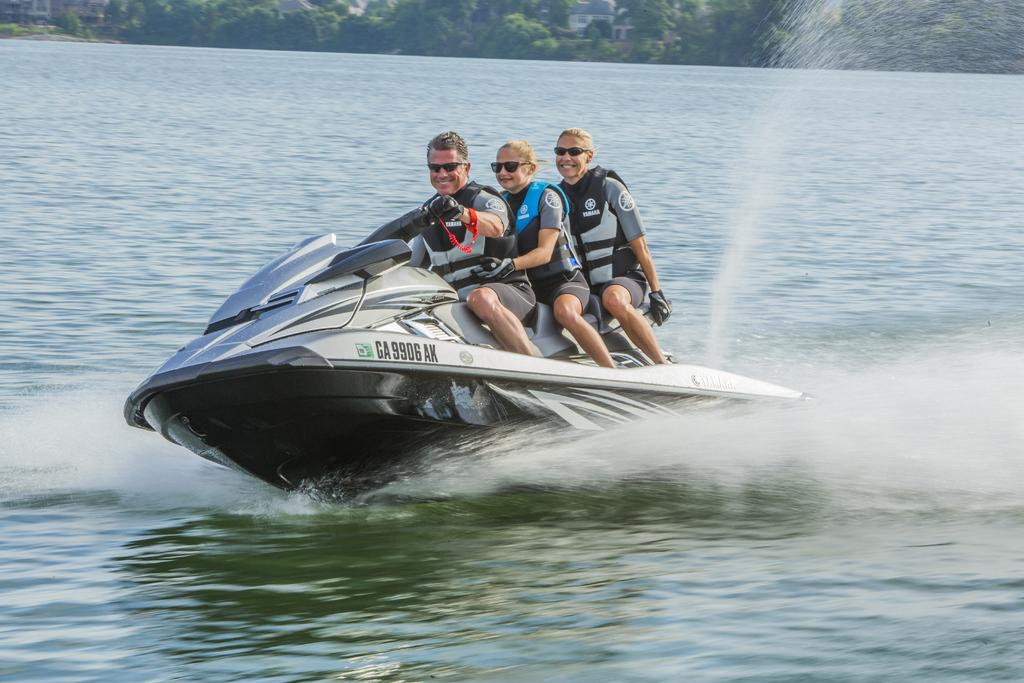How many people are in the image? There are three persons in the image. What are the persons doing in the image? The persons are sitting on a "Jet Ski". Where is the "Jet Ski" located in the image? The "Jet Ski" is on the water. What can be seen in the background of the image? Trees and buildings are visible at the top of the image. What type of bells can be heard ringing in the image? There are no bells present in the image, and therefore no sound can be heard. What is the person on the left holding in the image? The provided facts do not mention any objects being held by the persons on the "Jet Ski". 